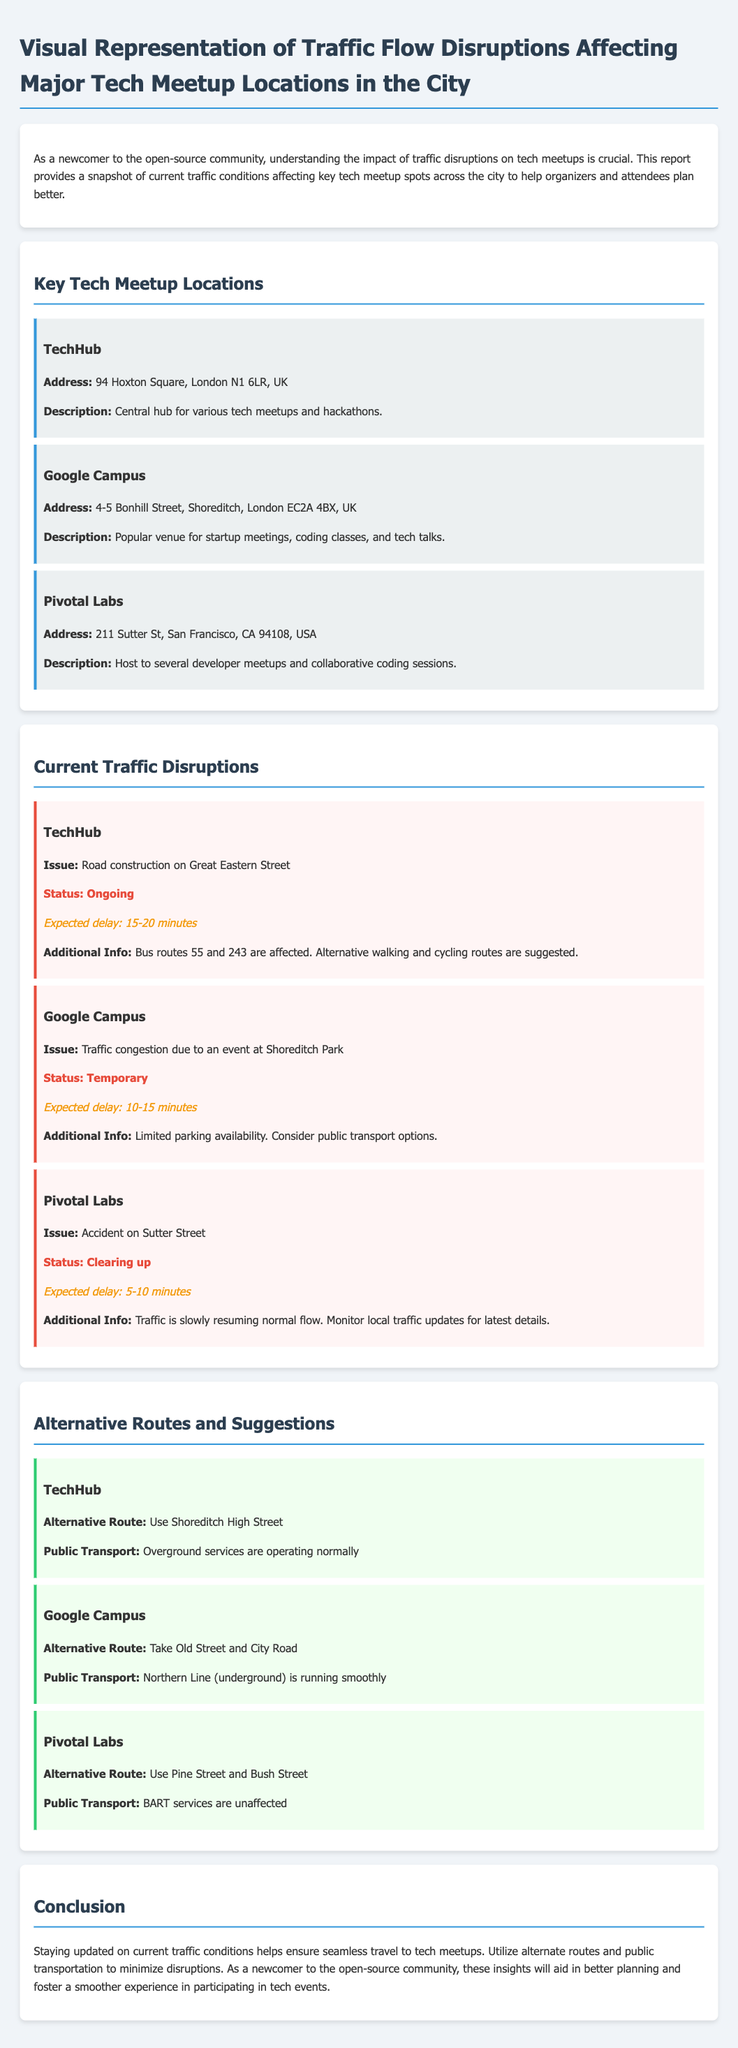what is the address of TechHub? TechHub is located at 94 Hoxton Square, London N1 6LR, UK.
Answer: 94 Hoxton Square, London N1 6LR, UK what is the expected delay at Google Campus? The expected delay at Google Campus due to traffic congestion is 10-15 minutes.
Answer: 10-15 minutes what is the alternative route for TechHub? The alternative route for TechHub is to use Shoreditch High Street.
Answer: Shoreditch High Street what disruption is occurring at Pivotal Labs? The disruption at Pivotal Labs is an accident on Sutter Street.
Answer: Accident on Sutter Street what is the status of the disruption at TechHub? The status of the disruption at TechHub is ongoing.
Answer: Ongoing why is there traffic congestion at Google Campus? The traffic congestion at Google Campus is due to an event at Shoreditch Park.
Answer: An event at Shoreditch Park which public transport service is running smoothly for Google Campus? The Northern Line (underground) is running smoothly for Google Campus.
Answer: Northern Line (underground) what is the expected delay at Pivotal Labs? The expected delay at Pivotal Labs is 5-10 minutes as traffic is clearing up.
Answer: 5-10 minutes what is suggested for public transport options at Google Campus? It is suggested to consider public transport options due to limited parking availability.
Answer: Consider public transport options 